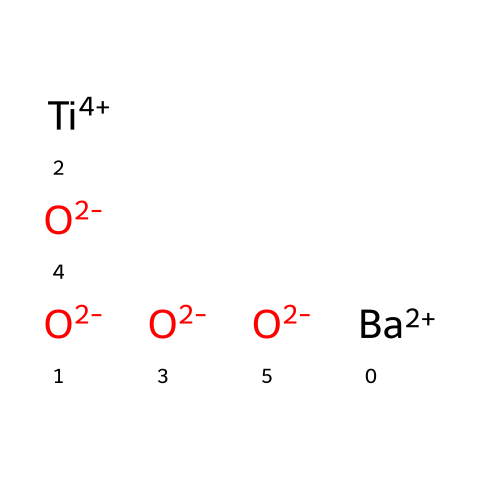What is the main component of barium titanate based on the chemical structure? The chemical structure indicates that barium (Ba), titanium (Ti), and oxygen (O) are present, with barium and titanium being the central components. The presence of titanium (in a +4 oxidation state) suggests it's the primary active component in barium titanate.
Answer: titanium How many oxygen atoms are present in the structure? The SMILES notation shows four oxygen atoms linked with barium and titanium. Counting the 'O' entries confirms there are four oxygen atoms.
Answer: four What is the oxidation state of titanium in this compound? The notation "[Ti+4]" explicitly indicates that titanium has an oxidation state of +4. This means that it has lost four electrons and is in a higher oxidation state, typical for titanium in titanate ceramics.
Answer: +4 How many total atoms are in the barium titanate structure? By adding each of the elements shown: 1 barium atom, 1 titanium atom, and 4 oxygen atoms, we find the total is 6 atoms. Thus, the sum results in six atoms in total.
Answer: six What type of materials can barium titanate form based on its properties? Barium titanate is known for forming ferroelectric materials due to its structure and the presence of polarizable titanium and oxygen. This can lead to applications in touch-sensitive interfaces like capacitors or sensors.
Answer: ferroelectric materials 